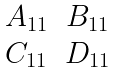<formula> <loc_0><loc_0><loc_500><loc_500>\begin{matrix} A _ { 1 1 } & B _ { 1 1 } \\ C _ { 1 1 } & D _ { 1 1 } \end{matrix}</formula> 